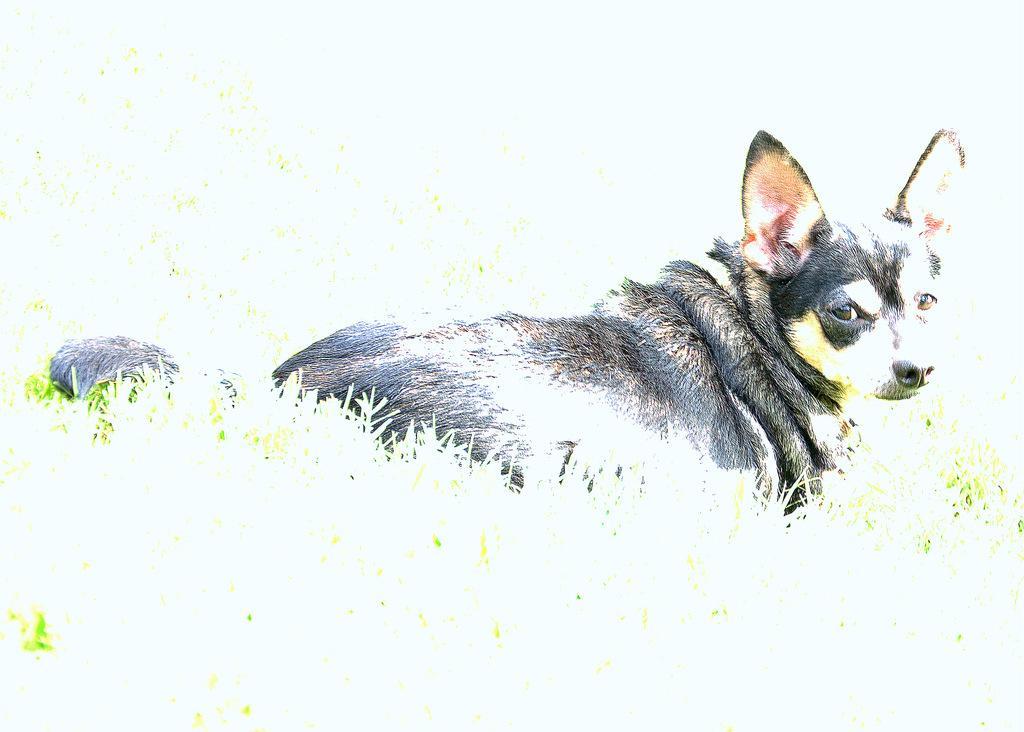Can you describe this image briefly? In this image I can see the dog in black and white color. I can see the grass and white color background. 